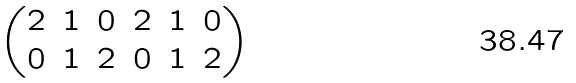<formula> <loc_0><loc_0><loc_500><loc_500>\begin{pmatrix} 2 & 1 & 0 & 2 & 1 & 0 \\ 0 & 1 & 2 & 0 & 1 & 2 \end{pmatrix}</formula> 